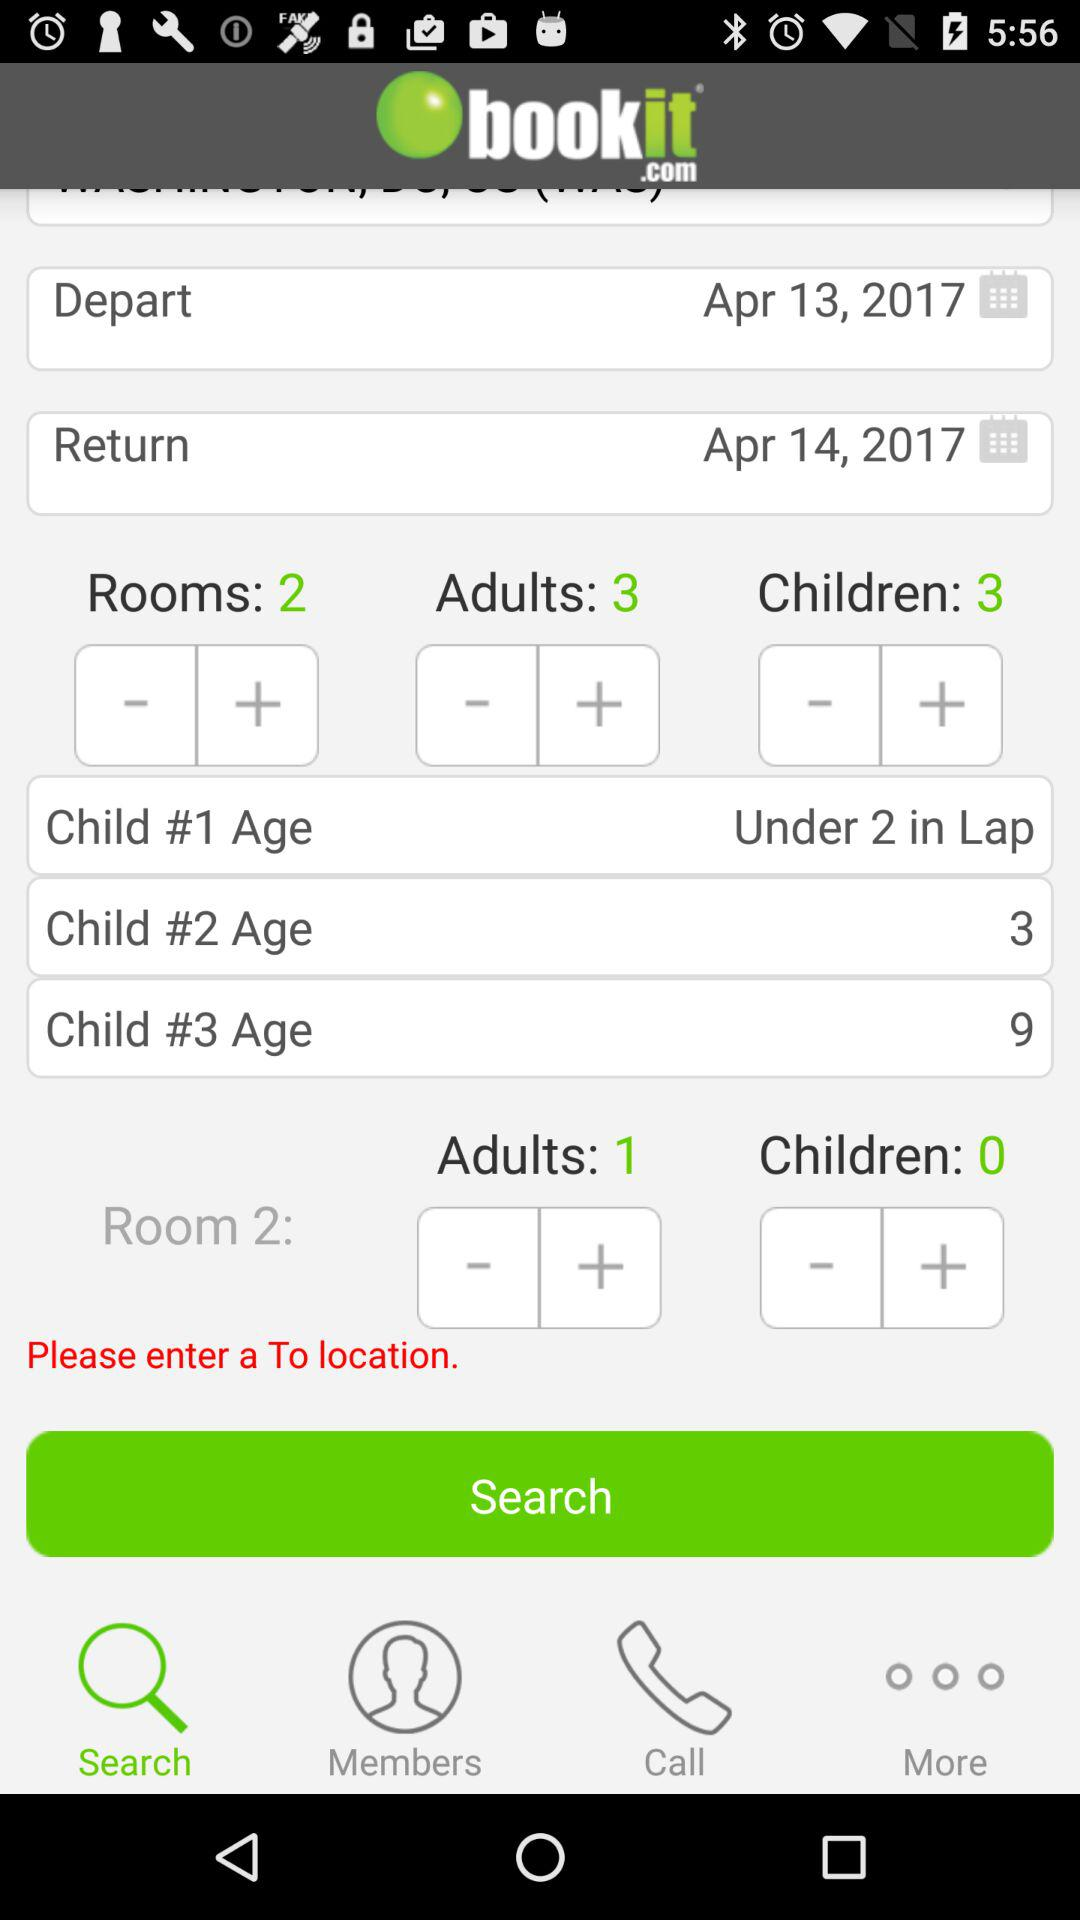What is the number of rooms added? The number of rooms added is 2. 